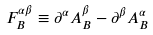<formula> <loc_0><loc_0><loc_500><loc_500>F _ { B } ^ { \alpha \beta } \equiv \partial ^ { \alpha } A _ { B } ^ { \beta } - \partial ^ { \beta } A _ { B } ^ { \alpha }</formula> 